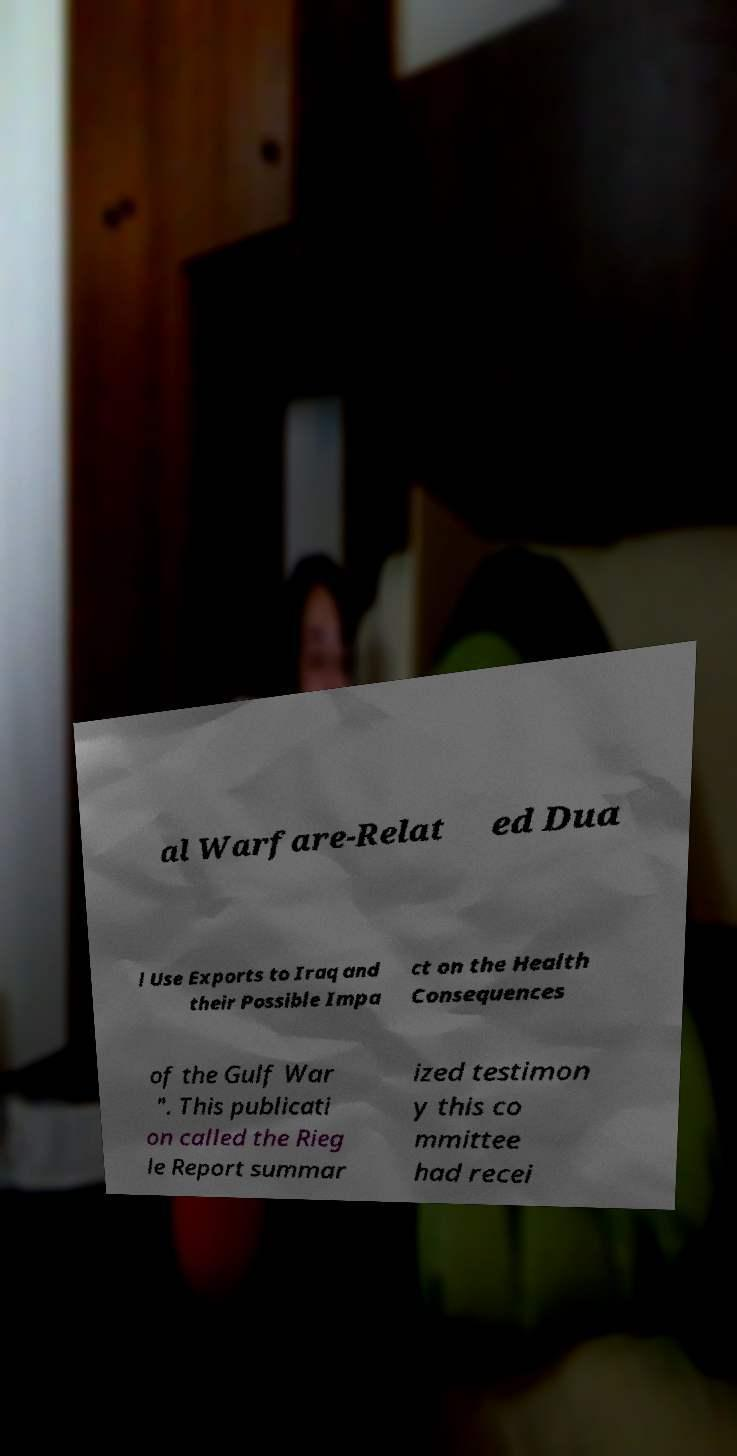What messages or text are displayed in this image? I need them in a readable, typed format. al Warfare-Relat ed Dua l Use Exports to Iraq and their Possible Impa ct on the Health Consequences of the Gulf War ". This publicati on called the Rieg le Report summar ized testimon y this co mmittee had recei 